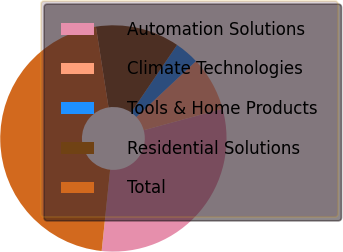<chart> <loc_0><loc_0><loc_500><loc_500><pie_chart><fcel>Automation Solutions<fcel>Climate Technologies<fcel>Tools & Home Products<fcel>Residential Solutions<fcel>Total<nl><fcel>30.87%<fcel>7.75%<fcel>3.51%<fcel>11.98%<fcel>45.88%<nl></chart> 